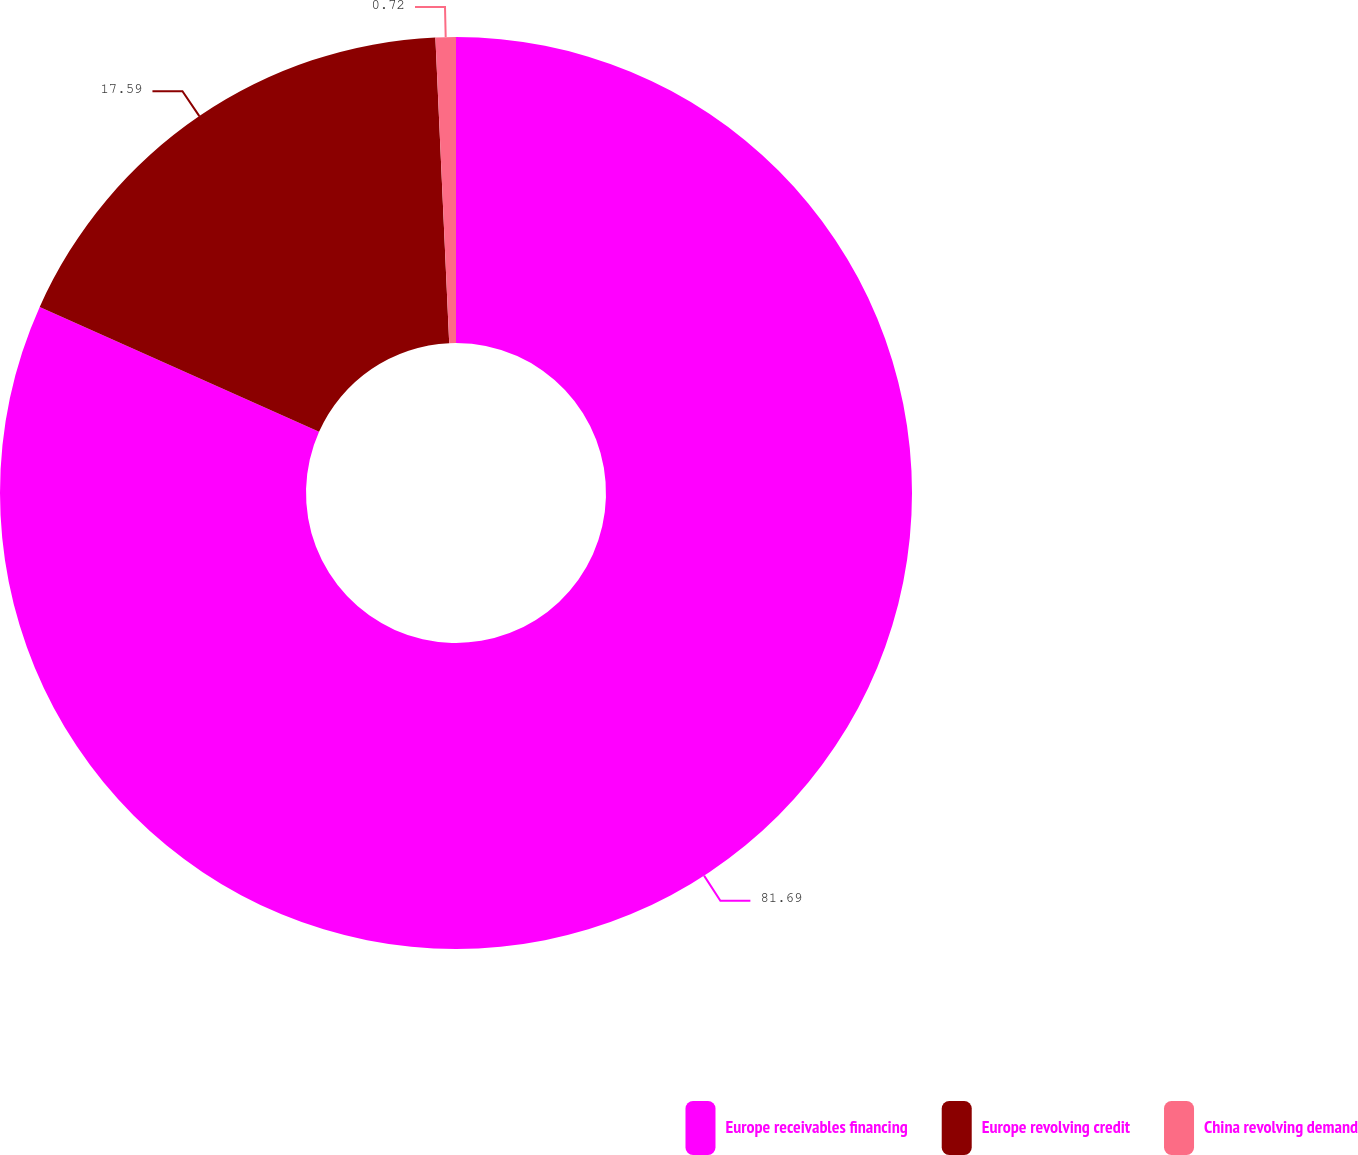Convert chart. <chart><loc_0><loc_0><loc_500><loc_500><pie_chart><fcel>Europe receivables financing<fcel>Europe revolving credit<fcel>China revolving demand<nl><fcel>81.69%<fcel>17.59%<fcel>0.72%<nl></chart> 